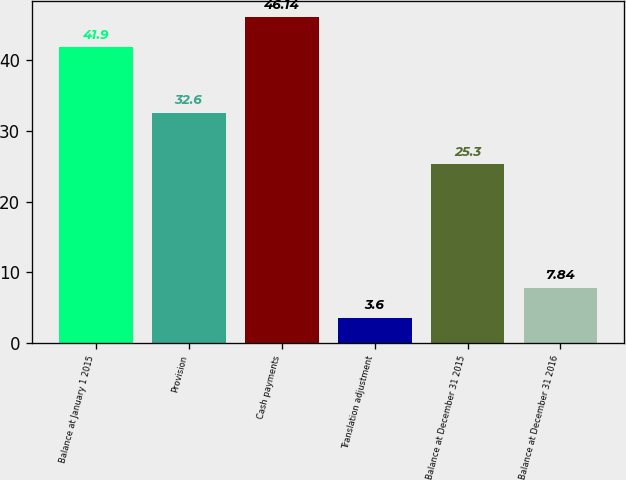Convert chart to OTSL. <chart><loc_0><loc_0><loc_500><loc_500><bar_chart><fcel>Balance at January 1 2015<fcel>Provision<fcel>Cash payments<fcel>Translation adjustment<fcel>Balance at December 31 2015<fcel>Balance at December 31 2016<nl><fcel>41.9<fcel>32.6<fcel>46.14<fcel>3.6<fcel>25.3<fcel>7.84<nl></chart> 